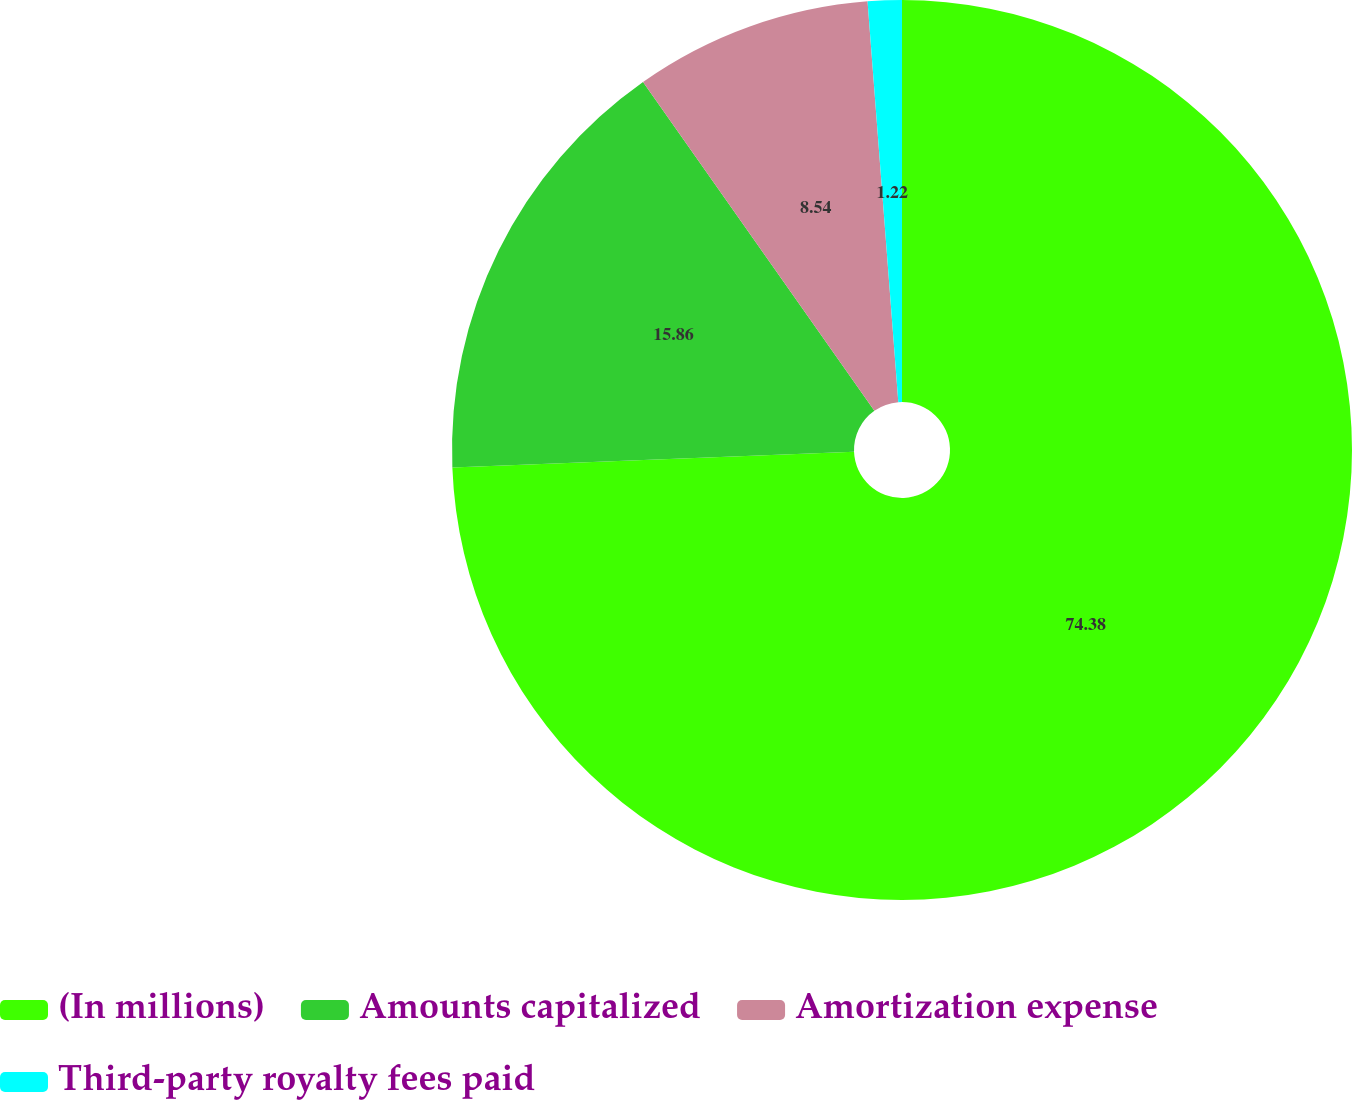Convert chart. <chart><loc_0><loc_0><loc_500><loc_500><pie_chart><fcel>(In millions)<fcel>Amounts capitalized<fcel>Amortization expense<fcel>Third-party royalty fees paid<nl><fcel>74.38%<fcel>15.86%<fcel>8.54%<fcel>1.22%<nl></chart> 